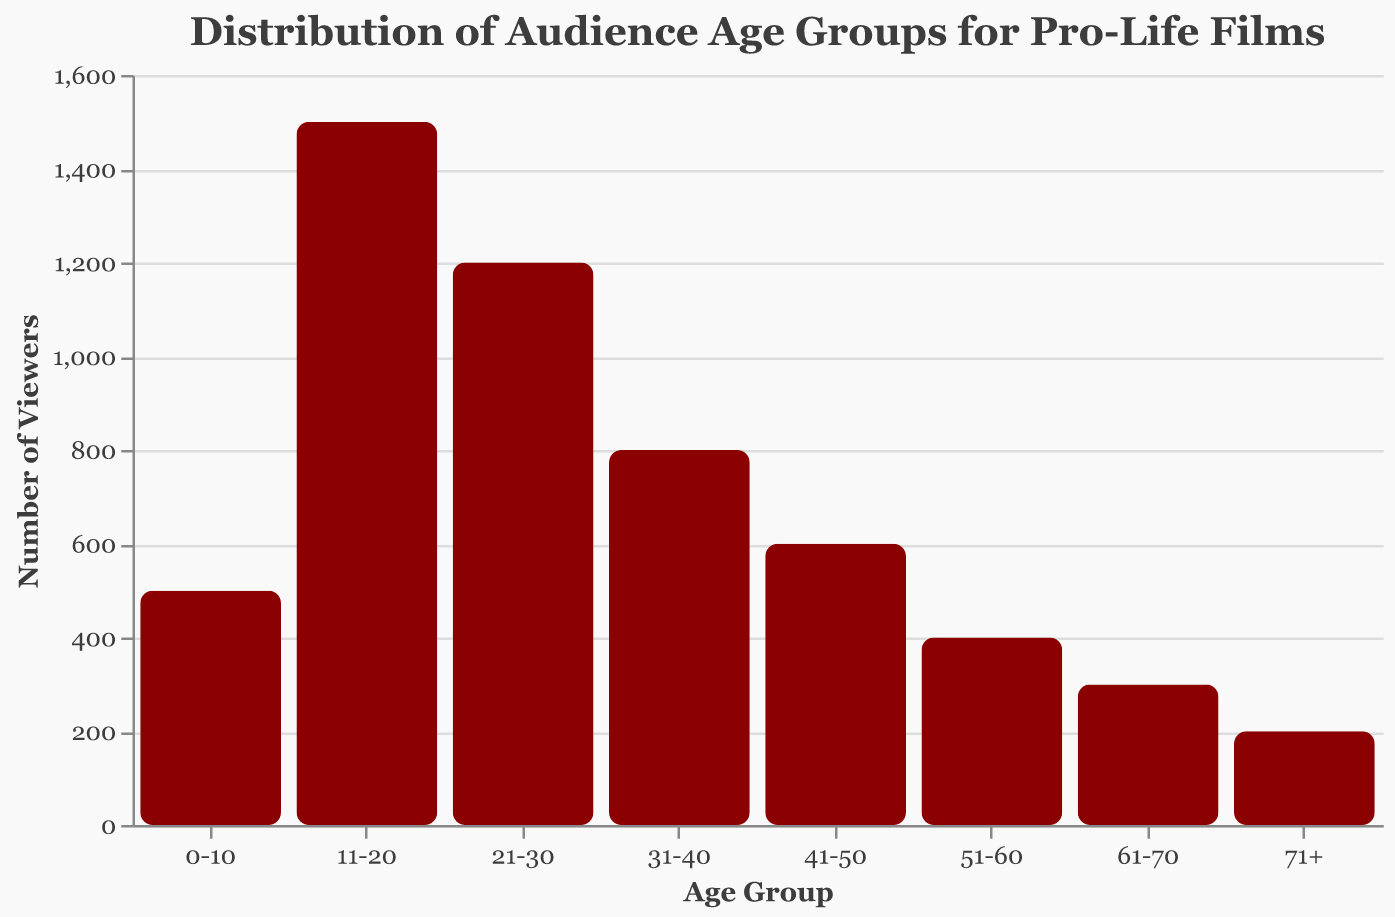What is the title of the plot? The title of the plot is the text at the top that provides a concise description of what the plot is about. It states "Distribution of Audience Age Groups for Pro-Life Films"
Answer: Distribution of Audience Age Groups for Pro-Life Films What age group has the highest number of viewers? By observing the height of the bars, we can see that the bar for the age group "11-20" is the tallest, indicating it has the highest number of viewers.
Answer: 11-20 What age group has the lowest number of viewers? By observing the height of the bars, we can see that the bar for the age group "71+" is the shortest, indicating it has the lowest number of viewers.
Answer: 71+ How many total viewers are there from the age groups 31-40 and 41-50 combined? The number of viewers for the age group 31-40 is 800 and for 41-50 is 600. Add these two numbers together: 800 + 600 = 1400.
Answer: 1400 What is the total number of viewers from age groups 0-10 and 61-70? The number of viewers for age group 0-10 is 500 and for 61-70 is 300. Add these two numbers together: 500 + 300 = 800.
Answer: 800 Which age group has more viewers: 21-30 or 51-60? Comparing the heights of the bars for the age groups 21-30 and 51-60, we see that the 21-30 age group's bar is taller. Therefore, 21-30 has more viewers.
Answer: 21-30 Which age groups have more than 1000 viewers? By looking at the y-axis and the bars, we see that the age groups with bars reaching above 1000 viewers are 11-20 and 21-30.
Answer: 11-20, 21-30 What is the sum of viewers from the youngest and the oldest age groups? The youngest age group (0-10) has 500 viewers, and the oldest age group (71+) has 200 viewers. Add these together: 500 + 200 = 700.
Answer: 700 What is the difference in the number of viewers between the age groups 31-40 and 41-50? The number of viewers for age group 31-40 is 800, and for 41-50 it is 600. Subtract 600 from 800 to get the difference: 800 - 600 = 200.
Answer: 200 Among the age groups 0-10, 41-50, and 61-70, which one has the median number of viewers? The counts for the age groups 0-10, 41-50, and 61-70 are 500, 600, and 300 respectively. When these numbers are sorted (300, 500, 600), the median is the middle number which is 500.
Answer: 0-10 